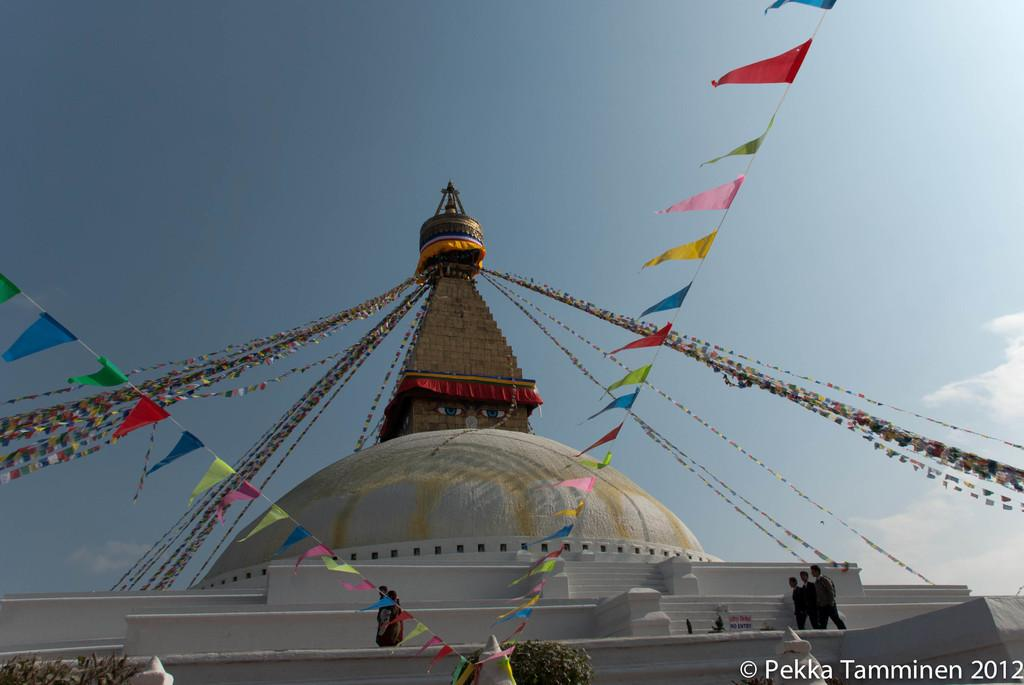What structure is located at the bottom of the image? There is a building at the bottom of the image. What is happening on the building? There are people standing on the building. What type of vegetation is near the building? There are plants near the building. What is visible at the top of the image? There are clouds and the sky visible at the top of the image. What type of music can be heard coming from the baby in the image? There is no baby present in the image, so it's not possible to determine what, if any, music might be heard. 